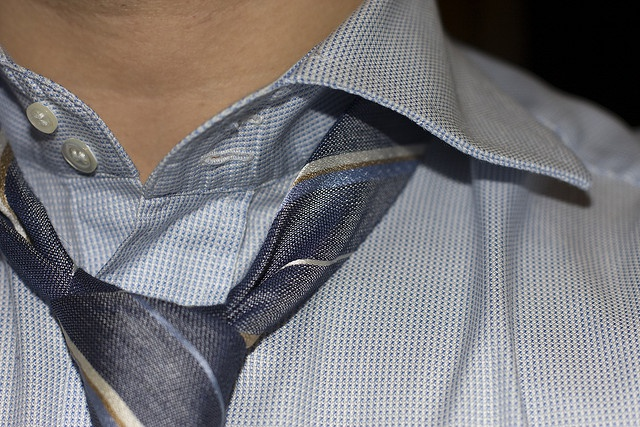Describe the objects in this image and their specific colors. I can see people in darkgray, gray, black, and lightgray tones and tie in brown, black, gray, and darkgray tones in this image. 